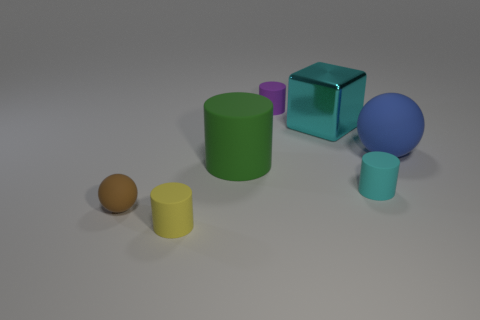Subtract all tiny purple matte cylinders. How many cylinders are left? 3 Subtract 1 balls. How many balls are left? 1 Add 1 big purple cylinders. How many objects exist? 8 Subtract all cyan cylinders. How many cylinders are left? 3 Subtract all spheres. How many objects are left? 5 Subtract all blue cylinders. Subtract all brown cubes. How many cylinders are left? 4 Add 6 cyan matte objects. How many cyan matte objects are left? 7 Add 7 large blue rubber spheres. How many large blue rubber spheres exist? 8 Subtract 0 cyan balls. How many objects are left? 7 Subtract all green spheres. How many green cylinders are left? 1 